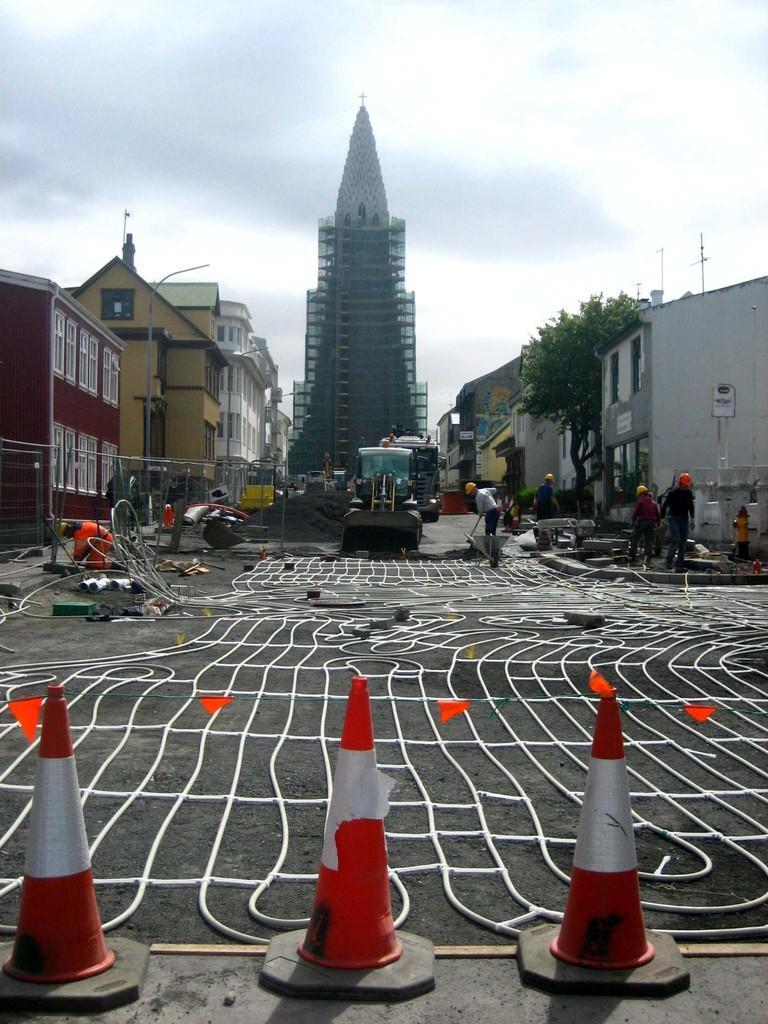Please provide a concise description of this image. In this picture I can observe traffic cones in the bottom of the picture. In the middle of the picture I can observe road. In the background there are buildings and some clouds in the sky. 